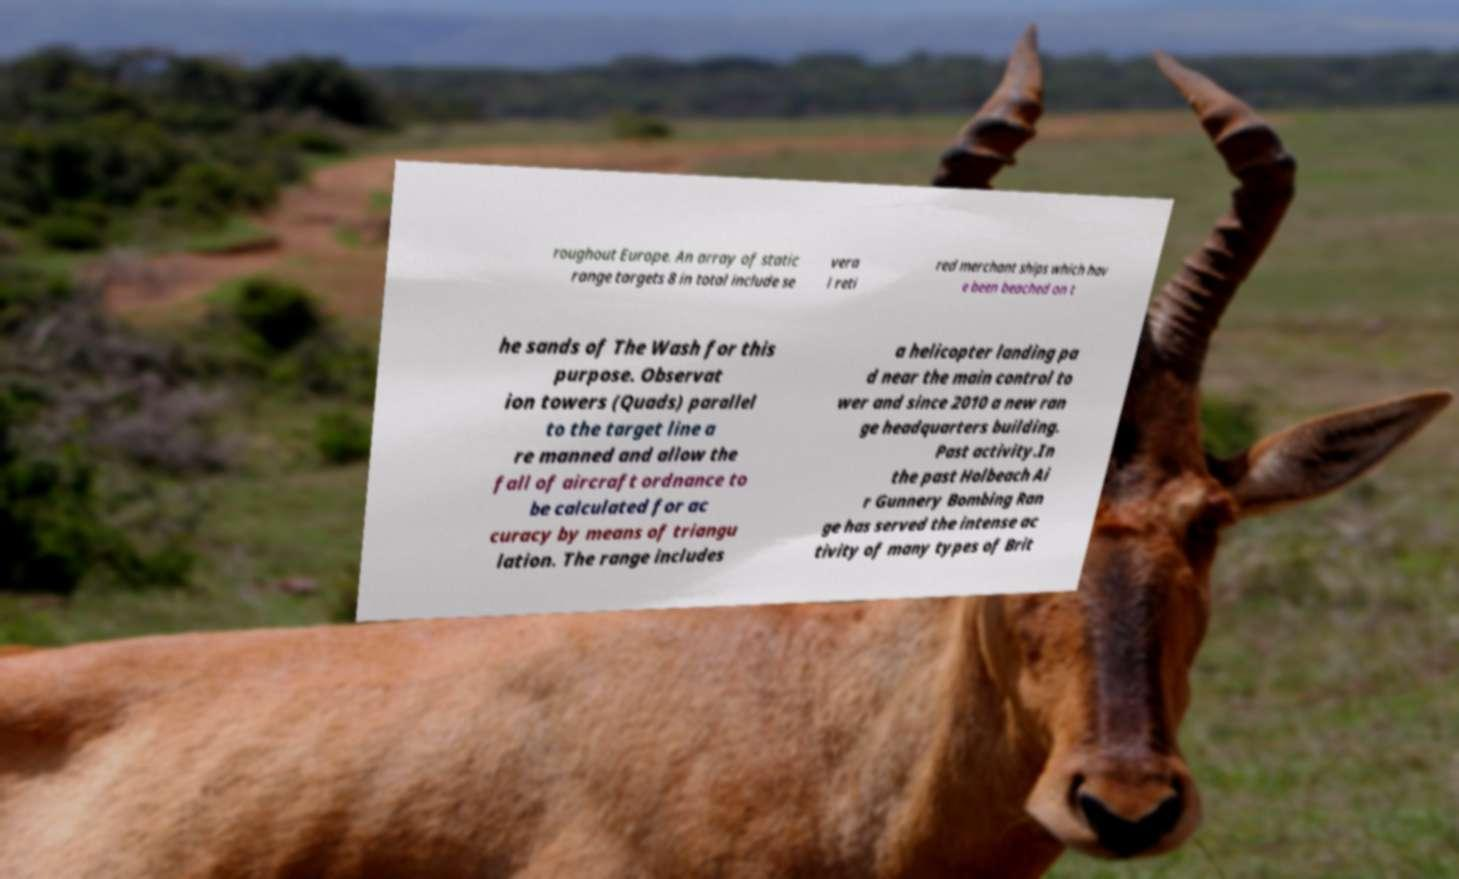Could you assist in decoding the text presented in this image and type it out clearly? roughout Europe. An array of static range targets 8 in total include se vera l reti red merchant ships which hav e been beached on t he sands of The Wash for this purpose. Observat ion towers (Quads) parallel to the target line a re manned and allow the fall of aircraft ordnance to be calculated for ac curacy by means of triangu lation. The range includes a helicopter landing pa d near the main control to wer and since 2010 a new ran ge headquarters building. Past activity.In the past Holbeach Ai r Gunnery Bombing Ran ge has served the intense ac tivity of many types of Brit 